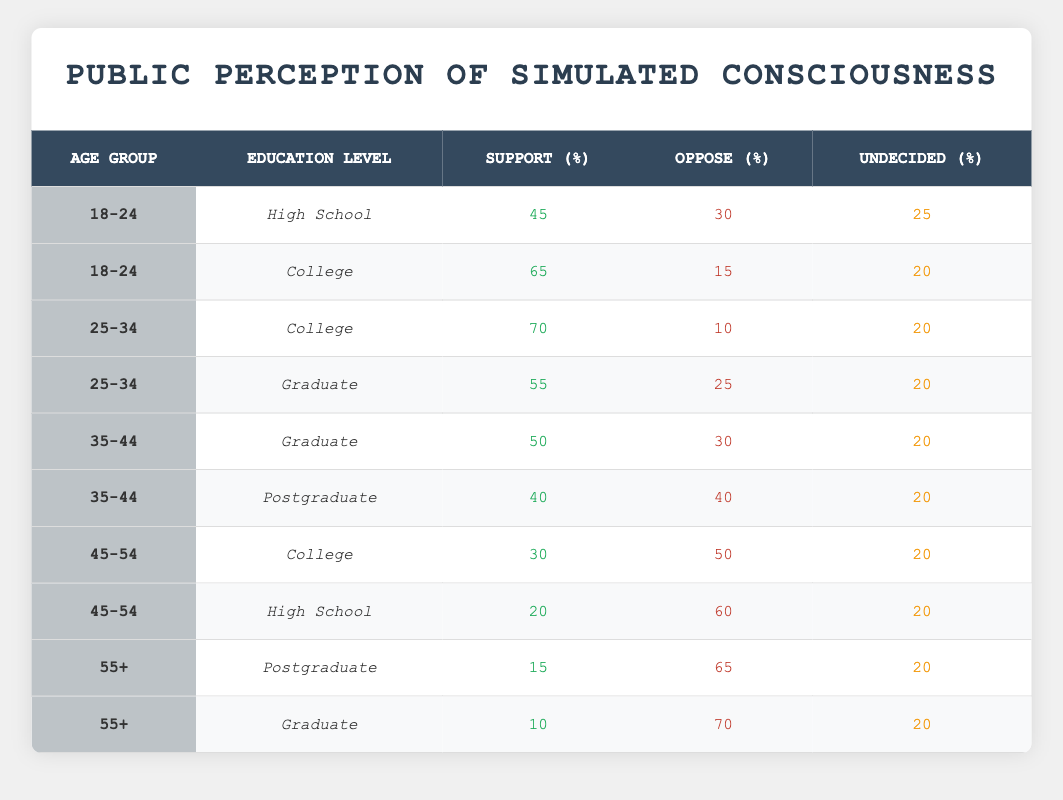What percentage of the 18-24 age group with a College education supports simulated consciousness? In the table, under the age group "18-24" and "College" education level, the support percentage is directly listed as 65.
Answer: 65 How many people in the 25-34 age group oppose simulated consciousness when they have a Graduate education? The table shows that in the "25-34" age group with "Graduate" education, the percentage opposing simulated consciousness is 25.
Answer: 25 Is the opposition to simulated consciousness in the 45-54 age group with a High School education greater than 50%? According to the table, the opposition percentage in the "45-54" age group with "High School" education is 60, which is indeed greater than 50%.
Answer: Yes What is the average percentage of support for simulated consciousness across all age groups with a College education? The support percentages for College education are 65 (18-24), 70 (25-34), and 30 (45-54). Adding them gives 65 + 70 + 30 = 165, and there are 3 data points, so the average is 165 / 3 = 55.
Answer: 55 Which age group and education level has the highest opposition to simulated consciousness? The maximum opposition percentage is 70, found in the "55+" age group with "Graduate" education.
Answer: 55+ Graduate What is the difference in support for simulated consciousness between the 35-44 age group with a Postgraduate education and the 25-34 age group with a Graduate education? The support percentage for the "35-44" age group with "Postgraduate" education is 40, and for "25-34" with "Graduate" education, it is 55. The difference is 55 - 40 = 15.
Answer: 15 How many groups have undecided percentages of 20? Scanning the table, the percentage of undecided is 20 for all but one entry. There are a total of 9 entries, and 8 have 20% undecided.
Answer: 8 Is there a higher percentage of support for simulated consciousness among the younger populations (18-24 and 25-34) compared to older populations (45-54 and 55+)? For the younger populations (averaging 65%) versus the older populations (averaging 17.5%), it shows that the younger populations indeed have a higher percentage of support since 65 > 17.5.
Answer: Yes 